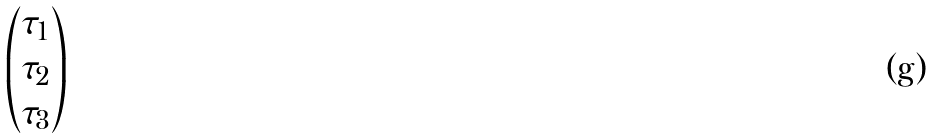<formula> <loc_0><loc_0><loc_500><loc_500>\begin{pmatrix} \tau _ { 1 } \\ \tau _ { 2 } \\ \tau _ { 3 } \\ \end{pmatrix}</formula> 